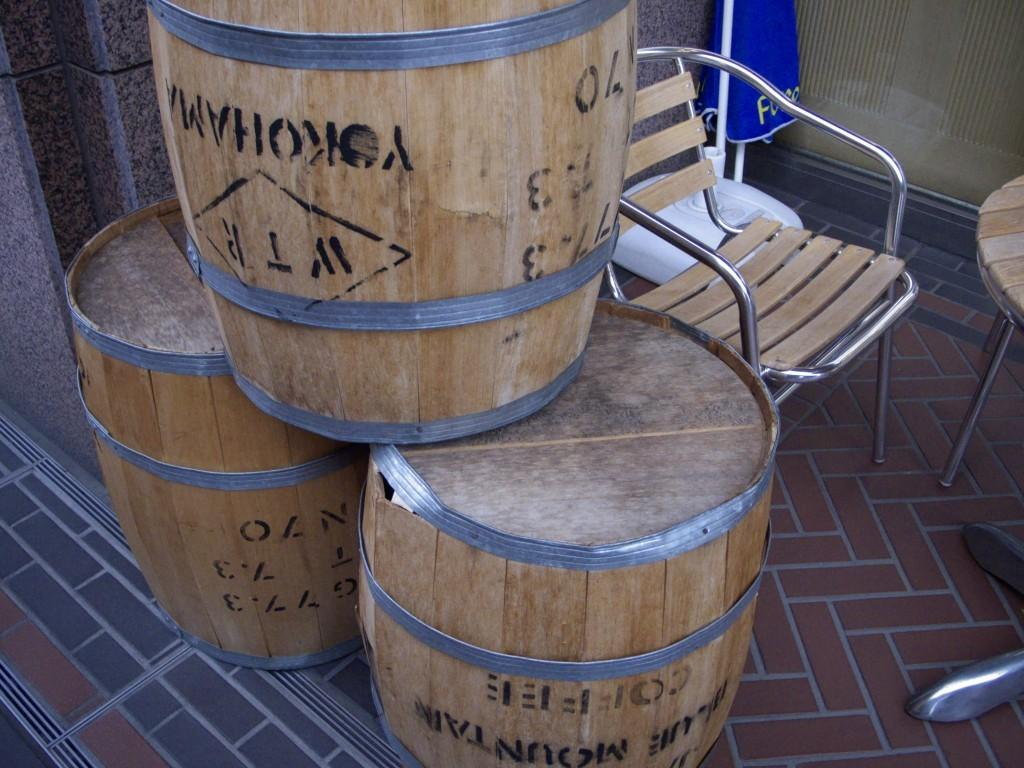How many barrels are visible in the image? There are three barrels in the image. What type of furniture is present in the image? There is a chair and a table in the image. What is the background of the image? There is a wall in the image. Where is the store located in the image? There is no store present in the image. What type of learning activity is taking place in the image? There is no learning activity depicted in the image. 